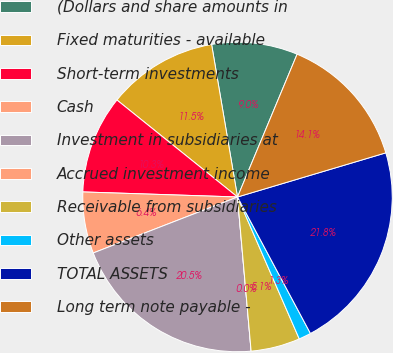Convert chart. <chart><loc_0><loc_0><loc_500><loc_500><pie_chart><fcel>(Dollars and share amounts in<fcel>Fixed maturities - available<fcel>Short-term investments<fcel>Cash<fcel>Investment in subsidiaries at<fcel>Accrued investment income<fcel>Receivable from subsidiaries<fcel>Other assets<fcel>TOTAL ASSETS<fcel>Long term note payable -<nl><fcel>8.97%<fcel>11.54%<fcel>10.26%<fcel>6.41%<fcel>20.51%<fcel>0.0%<fcel>5.13%<fcel>1.28%<fcel>21.79%<fcel>14.1%<nl></chart> 